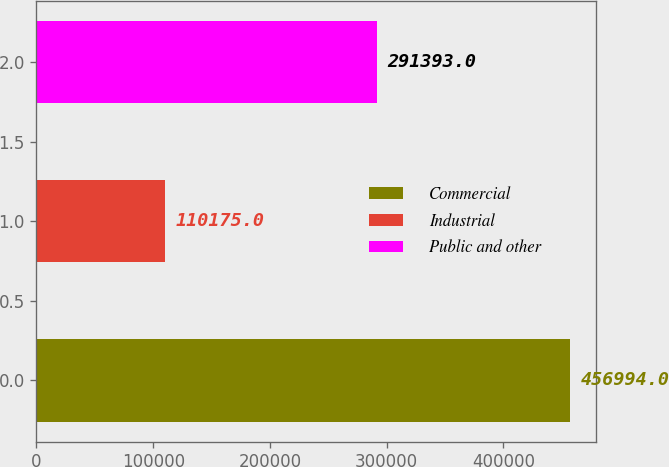Convert chart to OTSL. <chart><loc_0><loc_0><loc_500><loc_500><bar_chart><fcel>Commercial<fcel>Industrial<fcel>Public and other<nl><fcel>456994<fcel>110175<fcel>291393<nl></chart> 